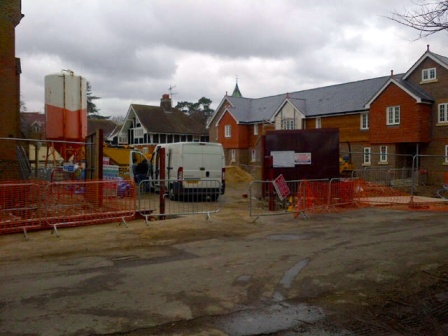How does the site integrate with the surrounding environment? The construction site appears to be set within a developing residential area. The presence of mature trees and established houses in the background suggests an attempt to blend new construction with the existing environment. The design and materials of the houses under construction might be chosen to complement the architectural style and setting of the neighborhood, ensuring that the new additions feel like a natural extension rather than an intrusion. What steps could be taken to minimize the environmental impact of this construction project? To minimize the environmental impact, several measures could be implemented. Utilizing sustainable building materials and construction techniques can significantly reduce the carbon footprint. Implementing strict waste management protocols to recycle and responsibly dispose of construction debris is crucial. Additionally, ensuring that the machinery used is energy-efficient and emissions-compliant can mitigate air pollution. Protecting existing trees and green areas, incorporating green spaces into the design, and managing water runoff effectively to prevent soil erosion and water pollution are also vital steps. 